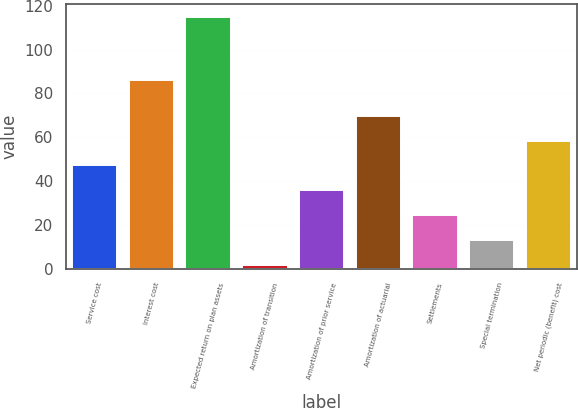Convert chart to OTSL. <chart><loc_0><loc_0><loc_500><loc_500><bar_chart><fcel>Service cost<fcel>Interest cost<fcel>Expected return on plan assets<fcel>Amortization of transition<fcel>Amortization of prior service<fcel>Amortization of actuarial<fcel>Settlements<fcel>Special termination<fcel>Net periodic (benefit) cost<nl><fcel>47.11<fcel>86<fcel>115<fcel>1.83<fcel>35.79<fcel>69.75<fcel>24.47<fcel>13.15<fcel>58.43<nl></chart> 